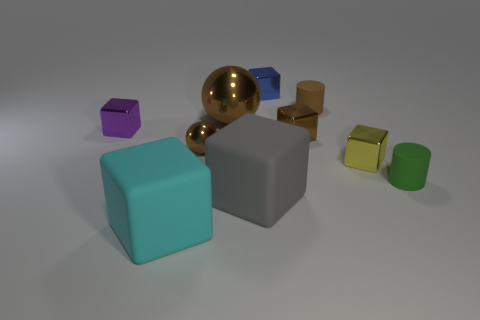Subtract 1 blocks. How many blocks are left? 5 Subtract all blue cubes. How many cubes are left? 5 Subtract all yellow blocks. How many blocks are left? 5 Subtract all gray blocks. Subtract all purple cylinders. How many blocks are left? 5 Subtract all spheres. How many objects are left? 8 Subtract 0 blue cylinders. How many objects are left? 10 Subtract all purple shiny spheres. Subtract all purple things. How many objects are left? 9 Add 7 yellow metal objects. How many yellow metal objects are left? 8 Add 5 purple cylinders. How many purple cylinders exist? 5 